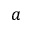Convert formula to latex. <formula><loc_0><loc_0><loc_500><loc_500>a</formula> 